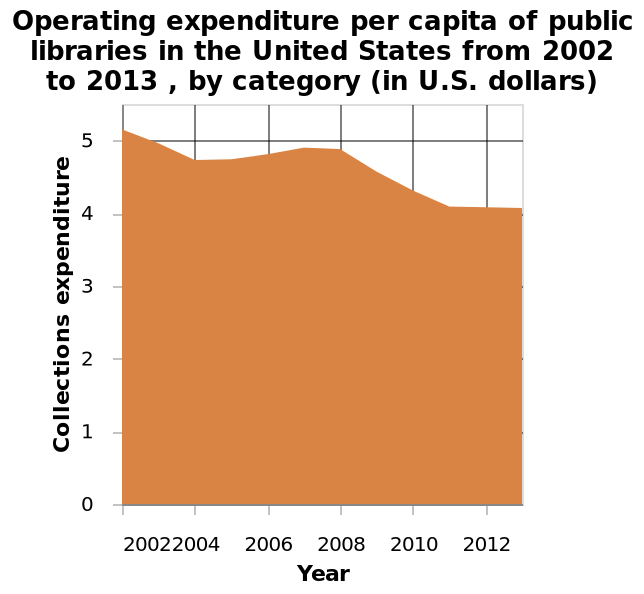<image>
How did the operating expenditure of public libraries change between 2002 and 2013?  The operating expenditure of public libraries generally decreased during this period. In which year were the operating expenditures of public libraries the highest?  The operating expenditures of public libraries were highest in 2002. 